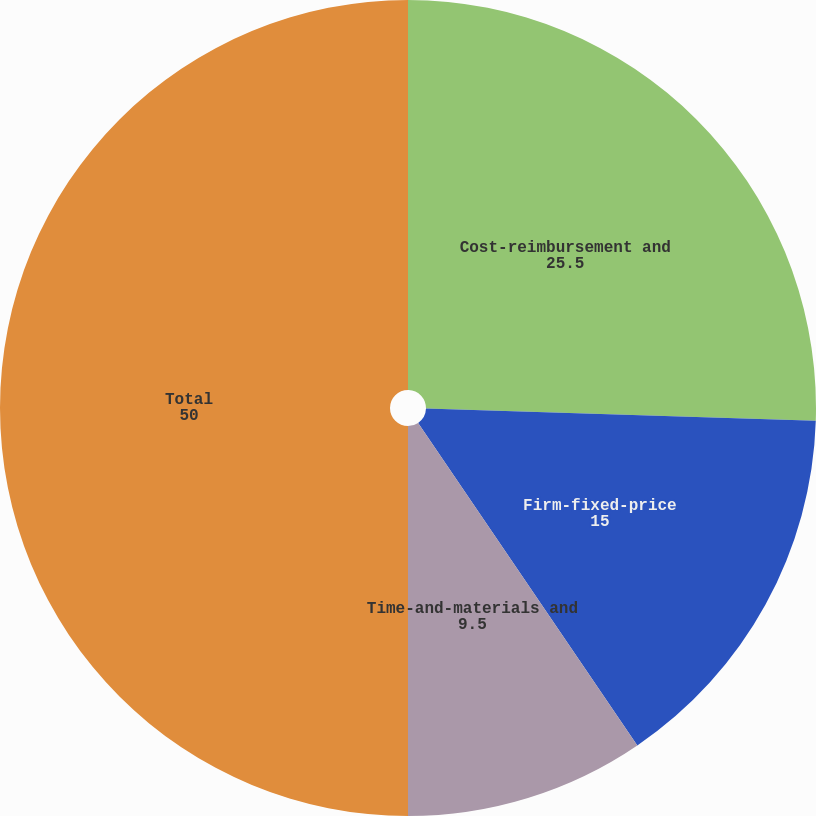Convert chart. <chart><loc_0><loc_0><loc_500><loc_500><pie_chart><fcel>Cost-reimbursement and<fcel>Firm-fixed-price<fcel>Time-and-materials and<fcel>Total<nl><fcel>25.5%<fcel>15.0%<fcel>9.5%<fcel>50.0%<nl></chart> 